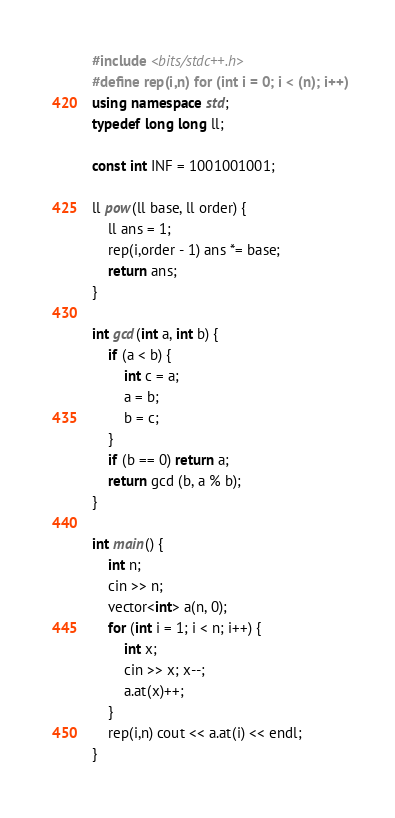Convert code to text. <code><loc_0><loc_0><loc_500><loc_500><_C++_>#include <bits/stdc++.h>
#define rep(i,n) for (int i = 0; i < (n); i++)
using namespace std;
typedef long long ll;

const int INF = 1001001001;

ll pow(ll base, ll order) {
	ll ans = 1;
	rep(i,order - 1) ans *= base;
	return ans;
}

int gcd(int a, int b) {
	if (a < b) {
		int c = a;
		a = b;
		b = c;
	}
	if (b == 0) return a;
	return gcd (b, a % b);
}

int main() {
	int n;
	cin >> n;
	vector<int> a(n, 0);
	for (int i = 1; i < n; i++) {
		int x;
		cin >> x; x--;
		a.at(x)++;
	}
	rep(i,n) cout << a.at(i) << endl;
}
</code> 